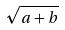Convert formula to latex. <formula><loc_0><loc_0><loc_500><loc_500>\sqrt { a + b }</formula> 